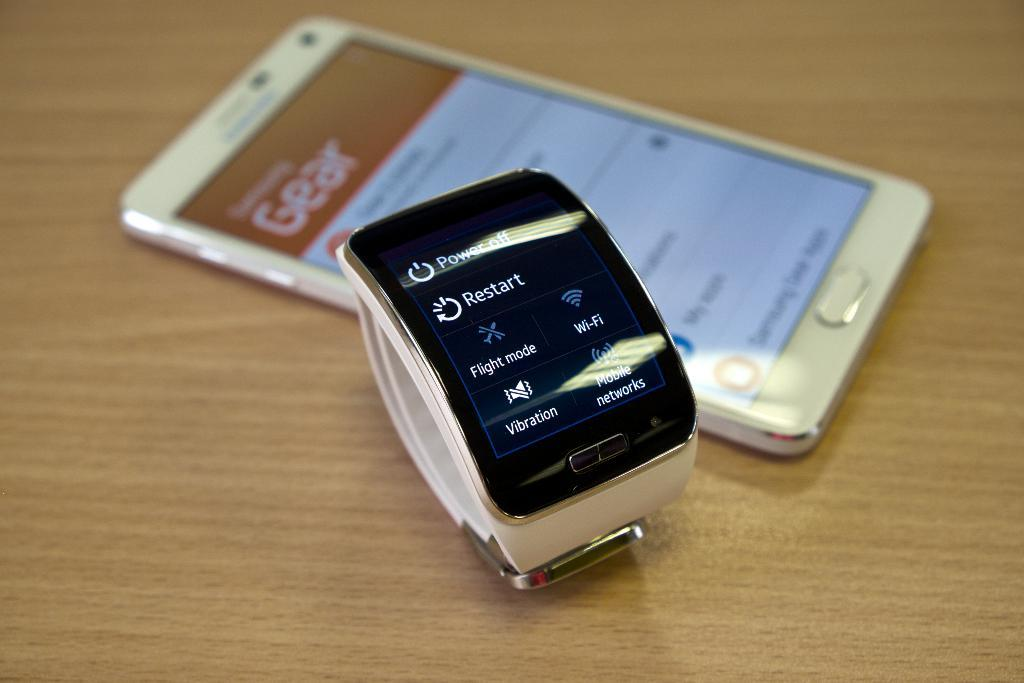<image>
Offer a succinct explanation of the picture presented. An ipod and watch are on a table set to restart 